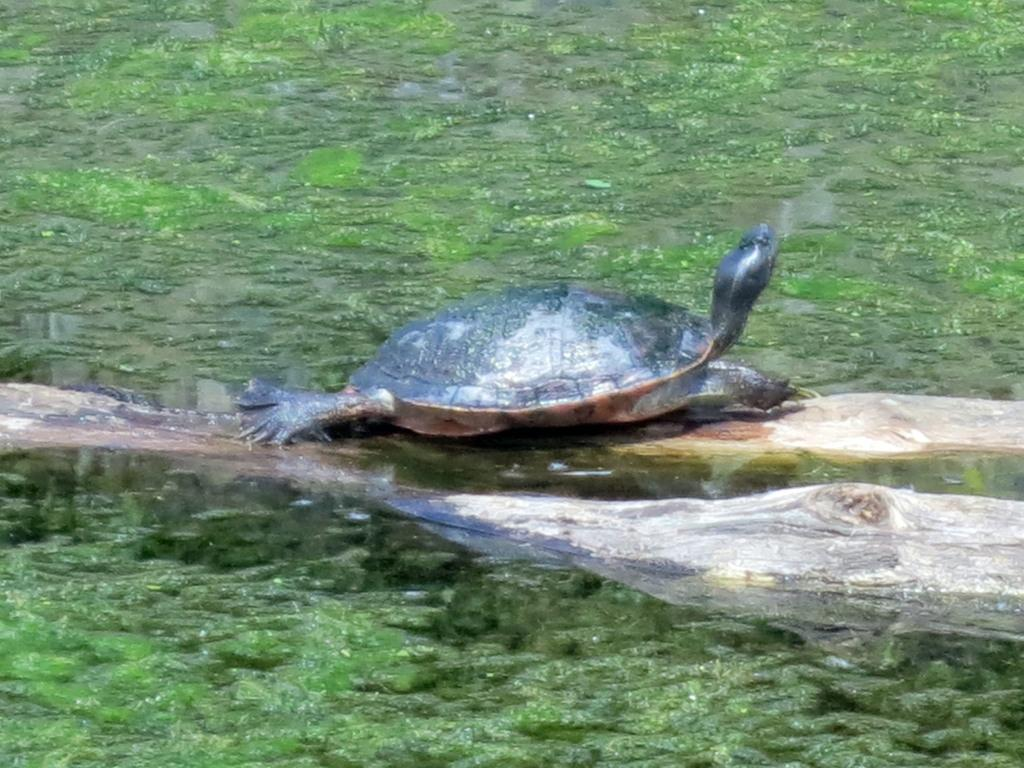What is present at the bottom of the image? There is water at the bottom of the image. What can be seen above the water in the image? There is a tortoise above the water in the image. What is the purpose of the sack in the image? There is no sack present in the image, so it is not possible to determine its purpose. 